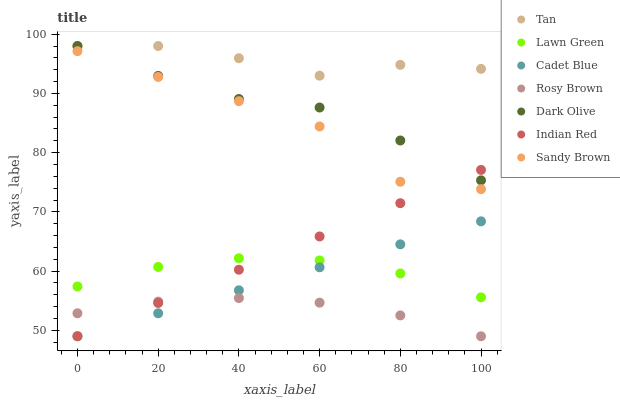Does Rosy Brown have the minimum area under the curve?
Answer yes or no. Yes. Does Tan have the maximum area under the curve?
Answer yes or no. Yes. Does Cadet Blue have the minimum area under the curve?
Answer yes or no. No. Does Cadet Blue have the maximum area under the curve?
Answer yes or no. No. Is Cadet Blue the smoothest?
Answer yes or no. Yes. Is Sandy Brown the roughest?
Answer yes or no. Yes. Is Dark Olive the smoothest?
Answer yes or no. No. Is Dark Olive the roughest?
Answer yes or no. No. Does Cadet Blue have the lowest value?
Answer yes or no. Yes. Does Dark Olive have the lowest value?
Answer yes or no. No. Does Tan have the highest value?
Answer yes or no. Yes. Does Cadet Blue have the highest value?
Answer yes or no. No. Is Sandy Brown less than Dark Olive?
Answer yes or no. Yes. Is Tan greater than Cadet Blue?
Answer yes or no. Yes. Does Cadet Blue intersect Lawn Green?
Answer yes or no. Yes. Is Cadet Blue less than Lawn Green?
Answer yes or no. No. Is Cadet Blue greater than Lawn Green?
Answer yes or no. No. Does Sandy Brown intersect Dark Olive?
Answer yes or no. No. 